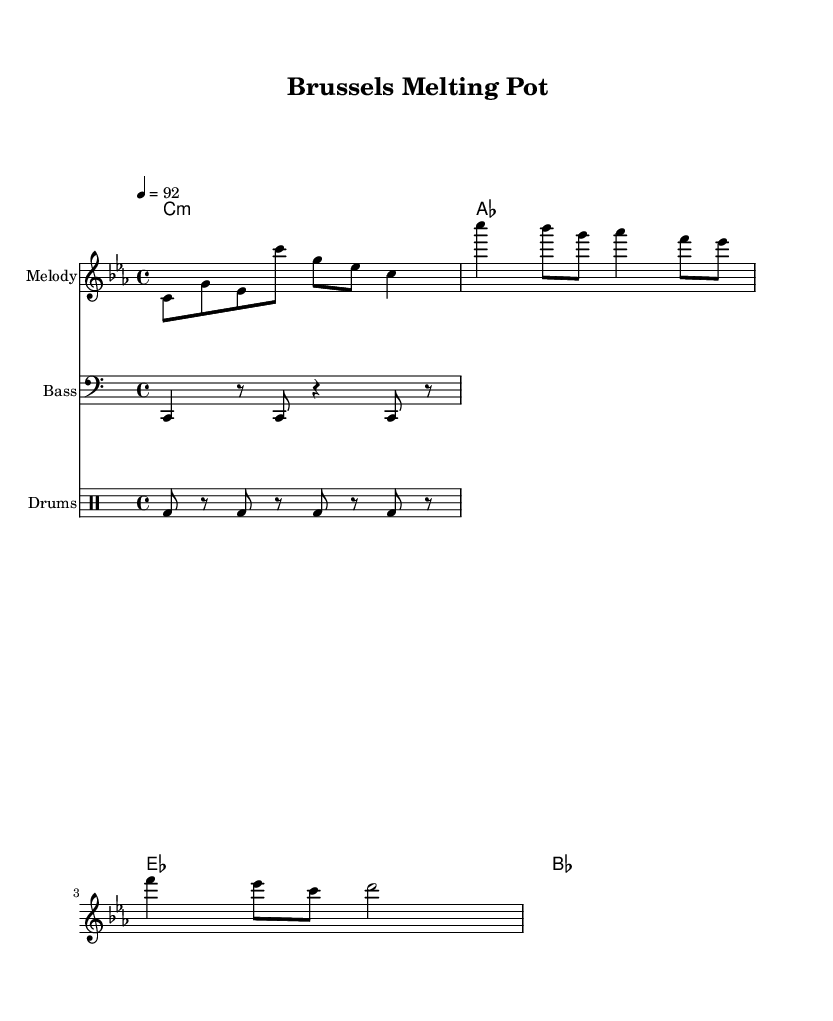What is the key signature of this music? The key signature indicates that this piece is in C minor, which has three flats: B flat, E flat, and A flat.
Answer: C minor What is the time signature of the music? The time signature is represented at the beginning of the score and shows that there are four beats per measure, with the quarter note getting the beat.
Answer: 4/4 What is the tempo marking for this piece? The tempo is specified at the beginning of the score, indicating that it should be played at a speed of 92 beats per minute.
Answer: 92 What is the primary genre of this music? The title and the context of the music suggest it’s a rap, focusing on cultural integration themes, which is characteristic of contemporary rap.
Answer: Rap How many measures are there in the chorus section? By counting the number of distinct grouped notes and rests in the chorus part of the score, we identify that there are two measures in this section.
Answer: 2 What instruments are indicated in this score? The score explicitly lists three types of instruments: a melody staff (likely for vocals or lead instruments), a bass staff, and a drum staff for rhythm.
Answer: Melody, Bass, Drums What chord is played at the beginning of the piece? The chord indicated at the beginning of the harmonic section in chord mode suggests a C minor chord, which aligns with the overall key signature.
Answer: C minor 